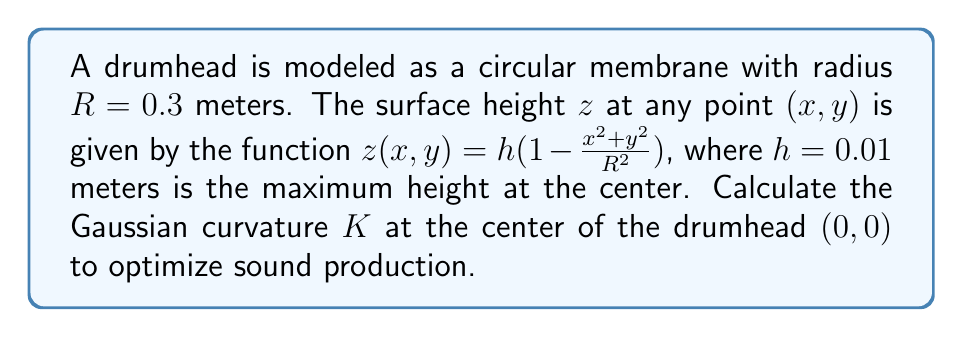Could you help me with this problem? To calculate the Gaussian curvature $K$ at the center of the drumhead, we'll follow these steps:

1) The Gaussian curvature $K$ is given by $K = \frac{LN - M^2}{EG - F^2}$, where $L$, $M$, $N$, $E$, $F$, and $G$ are coefficients of the first and second fundamental forms.

2) First, we need to calculate the partial derivatives:

   $$z_x = -\frac{2hx}{R^2}, \quad z_y = -\frac{2hy}{R^2}$$
   $$z_{xx} = -\frac{2h}{R^2}, \quad z_{yy} = -\frac{2h}{R^2}, \quad z_{xy} = 0$$

3) At the center $(0,0)$:
   
   $$z_x = 0, \quad z_y = 0$$
   $$z_{xx} = -\frac{2h}{R^2}, \quad z_{yy} = -\frac{2h}{R^2}, \quad z_{xy} = 0$$

4) Now we can calculate the coefficients:

   $$E = 1 + z_x^2 = 1$$
   $$F = z_x z_y = 0$$
   $$G = 1 + z_y^2 = 1$$
   $$L = \frac{z_{xx}}{\sqrt{1+z_x^2+z_y^2}} = -\frac{2h}{R^2}$$
   $$M = \frac{z_{xy}}{\sqrt{1+z_x^2+z_y^2}} = 0$$
   $$N = \frac{z_{yy}}{\sqrt{1+z_x^2+z_y^2}} = -\frac{2h}{R^2}$$

5) Substituting these into the formula for Gaussian curvature:

   $$K = \frac{LN - M^2}{EG - F^2} = \frac{(-\frac{2h}{R^2})(-\frac{2h}{R^2}) - 0^2}{1 \cdot 1 - 0^2} = \frac{4h^2}{R^4}$$

6) Now we can substitute the given values:

   $$K = \frac{4 \cdot (0.01)^2}{(0.3)^4} = \frac{0.0004}{0.0081} \approx 0.0494$$

Therefore, the Gaussian curvature $K$ at the center of the drumhead is approximately 0.0494 m^(-2).
Answer: $K \approx 0.0494$ m^(-2) 